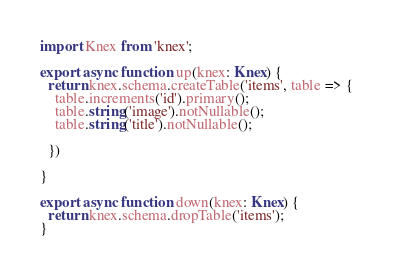<code> <loc_0><loc_0><loc_500><loc_500><_TypeScript_>import Knex from 'knex';

export async function up(knex: Knex) {
  return knex.schema.createTable('items', table => {
    table.increments('id').primary();
    table.string('image').notNullable();
    table.string('title').notNullable();

  })

}

export async function down(knex: Knex) {
  return knex.schema.dropTable('items');
}</code> 